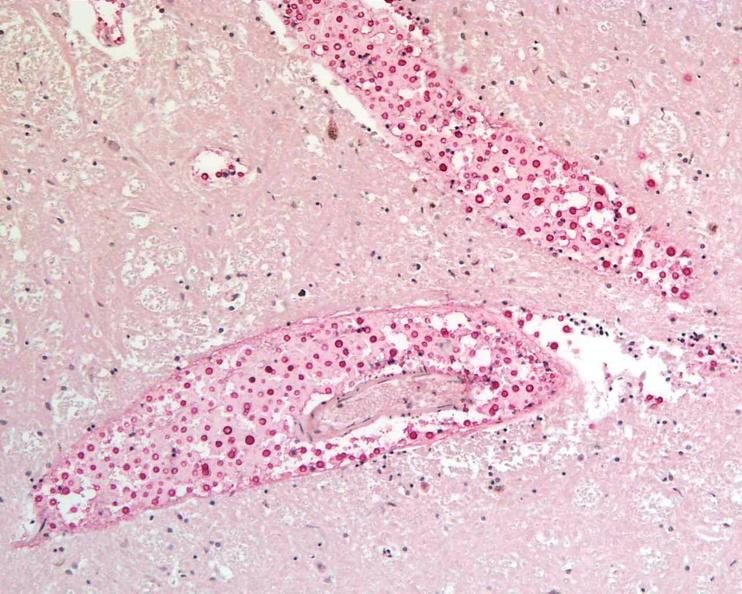s malaria plasmodium vivax present?
Answer the question using a single word or phrase. No 